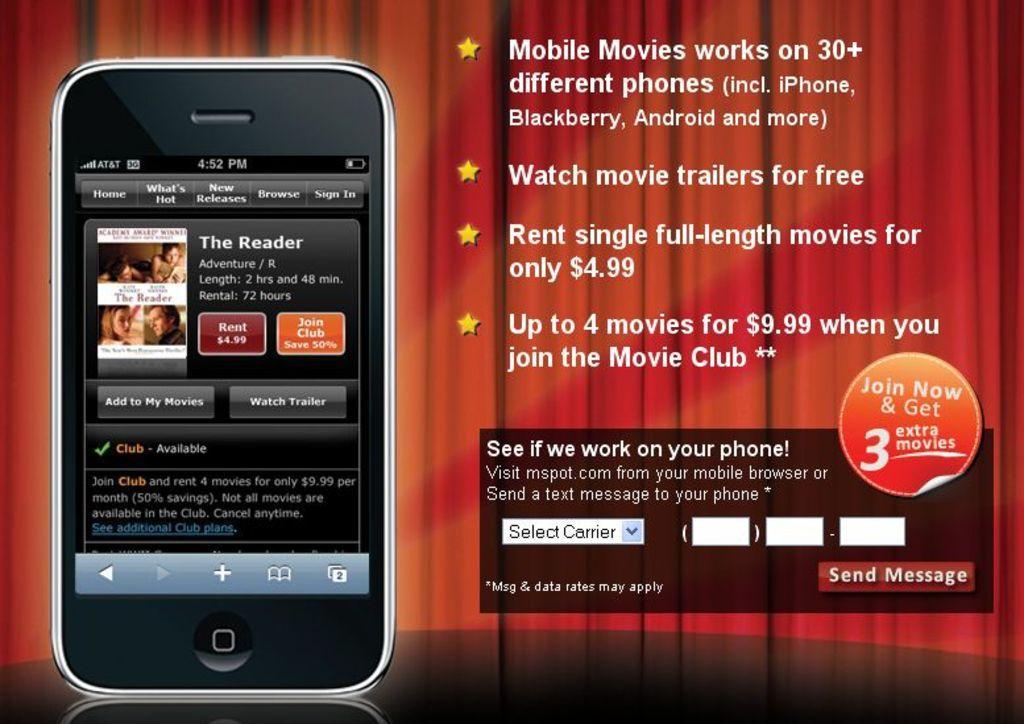In one or two sentences, can you explain what this image depicts? There is an image of a mobile phone. Some matter is written on the right. There are red curtains at the back. 